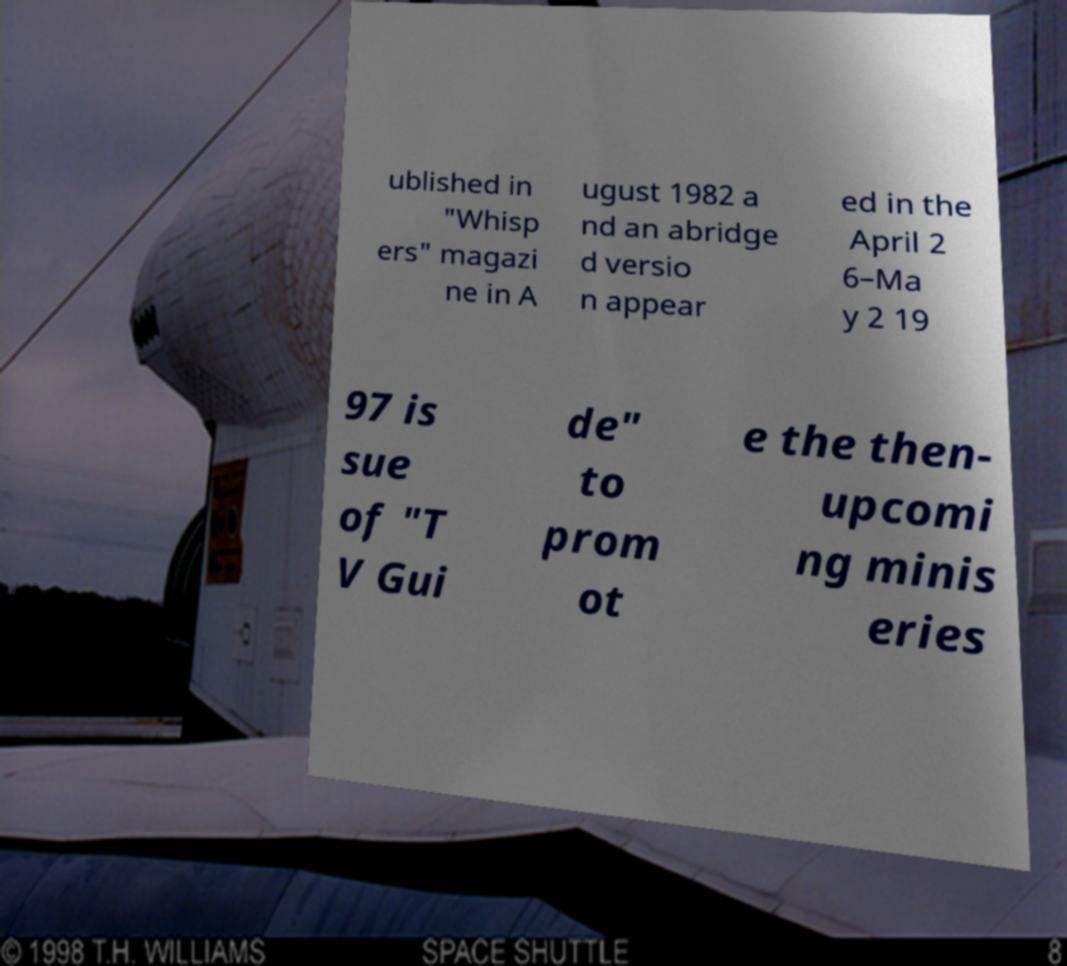Could you assist in decoding the text presented in this image and type it out clearly? ublished in "Whisp ers" magazi ne in A ugust 1982 a nd an abridge d versio n appear ed in the April 2 6–Ma y 2 19 97 is sue of "T V Gui de" to prom ot e the then- upcomi ng minis eries 